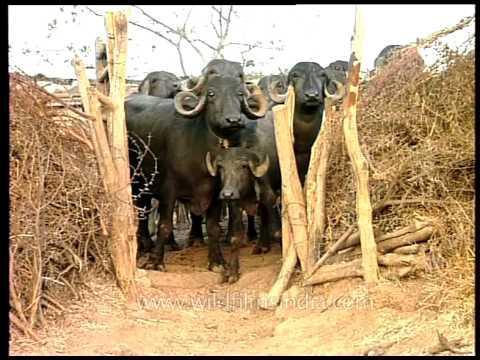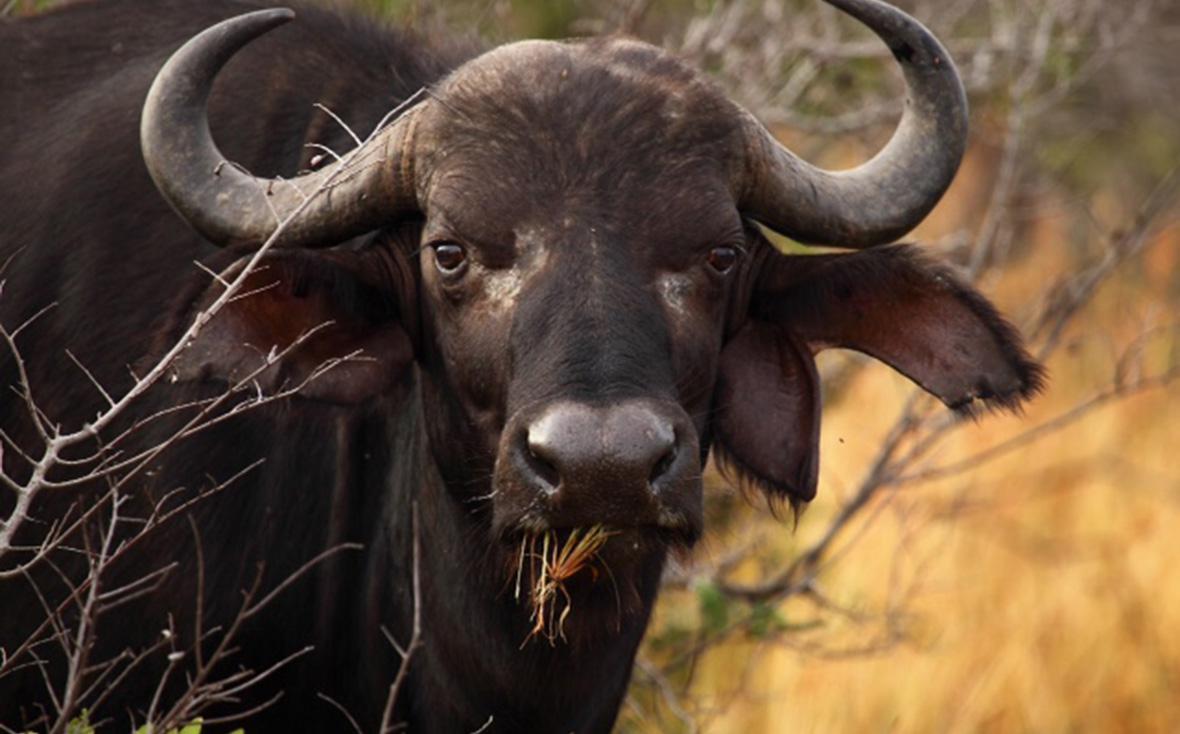The first image is the image on the left, the second image is the image on the right. Assess this claim about the two images: "there are some oxen in water.". Correct or not? Answer yes or no. No. The first image is the image on the left, the second image is the image on the right. Analyze the images presented: Is the assertion "There is at least one human visible." valid? Answer yes or no. No. 